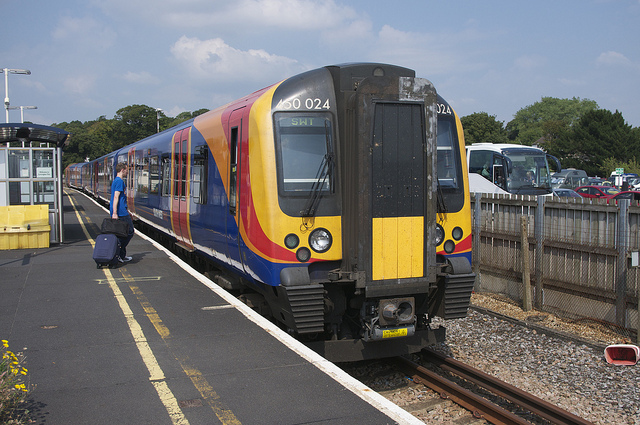Read all the text in this image. 024 450 024 